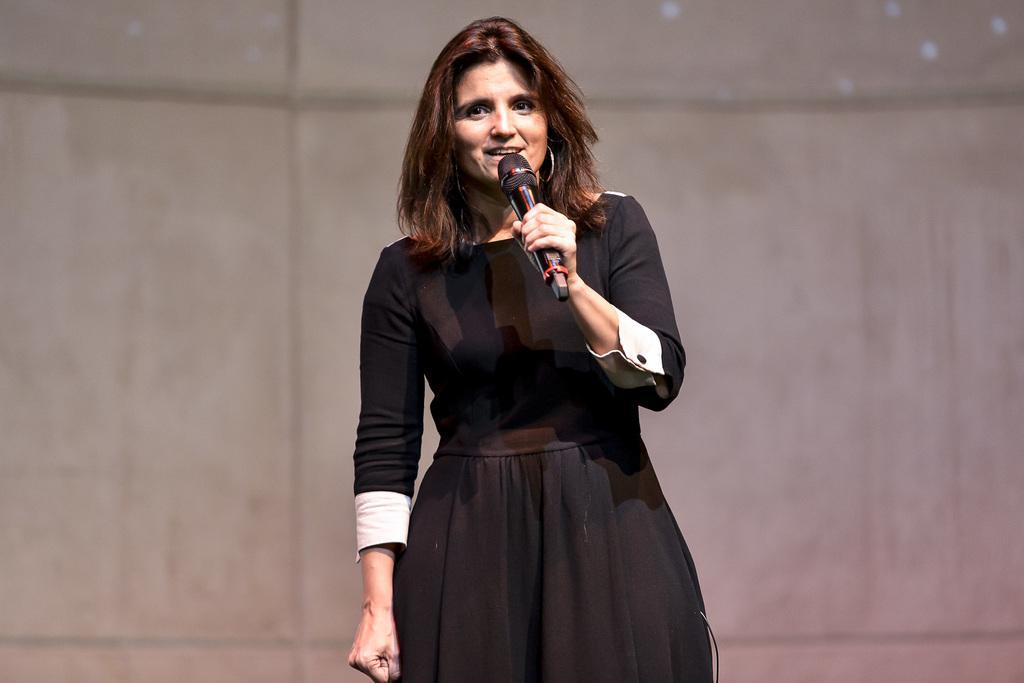Please provide a concise description of this image. This picture describes about a standing woman, she is talking with the help of microphone. 